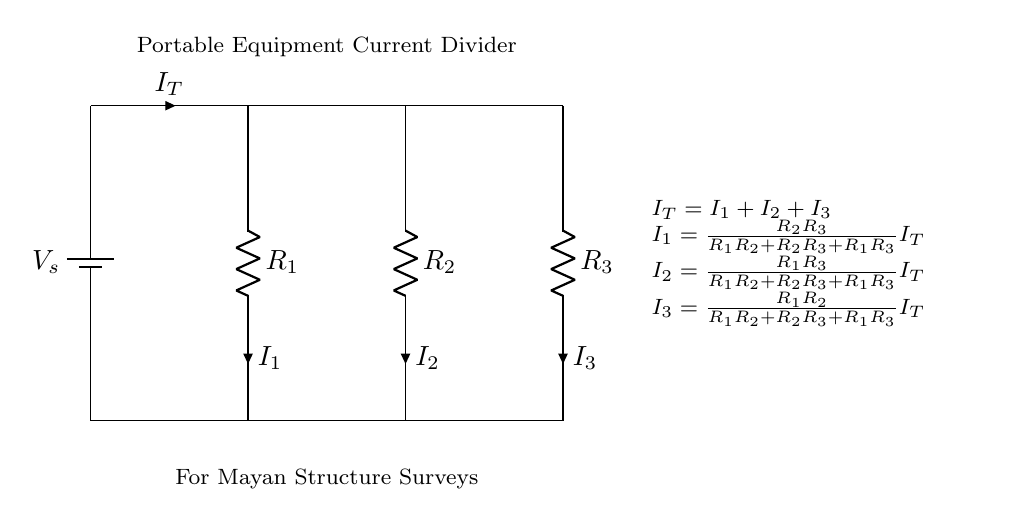What is the total current entering the divider? The total current entering the current divider is denoted as I_T, which appears on the main current path leading into the parallel resistors.
Answer: I_T How many resistors are involved in this circuit? There are three resistors connected in parallel in the current divider circuit, labeled as R_1, R_2, and R_3.
Answer: 3 What is the role of the battery in this circuit? The battery provides the source voltage, which is essential for the flow of current in the circuit. It supplies the potential difference necessary for the operation of the current divider.
Answer: Provides voltage Which resistor has the highest current in this circuit when I_T is constant? The current through each resistor can be determined using the current divider formulas provided. Typically, the smallest resistor will carry the highest current, so it would be important to look at their values. Since we don't have values, we can state that it depends on the resistance values to determine.
Answer: Depends on values What is the relationship between I_T and the individual currents I_1, I_2, and I_3? The relationship is defined by the equation I_T = I_1 + I_2 + I_3, indicating that the total current entering the divider splits into the individual currents through each resistor. This reflects the principle of conservation of charge.
Answer: I_T = I_1 + I_2 + I_3 How is the current I_1 calculated? I_1 can be calculated using the formula I_1 = (R_2 * R_3) / (R_1 * R_2 + R_2 * R_3 + R_1 * R_3) * I_T. This equation shows how the resistances affect the division of current between the branches.
Answer: I_1 = (R_2 * R_3) / (R_1 * R_2 + R_2 * R_3 + R_1 * R_3) * I_T 